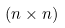<formula> <loc_0><loc_0><loc_500><loc_500>( n \times n )</formula> 